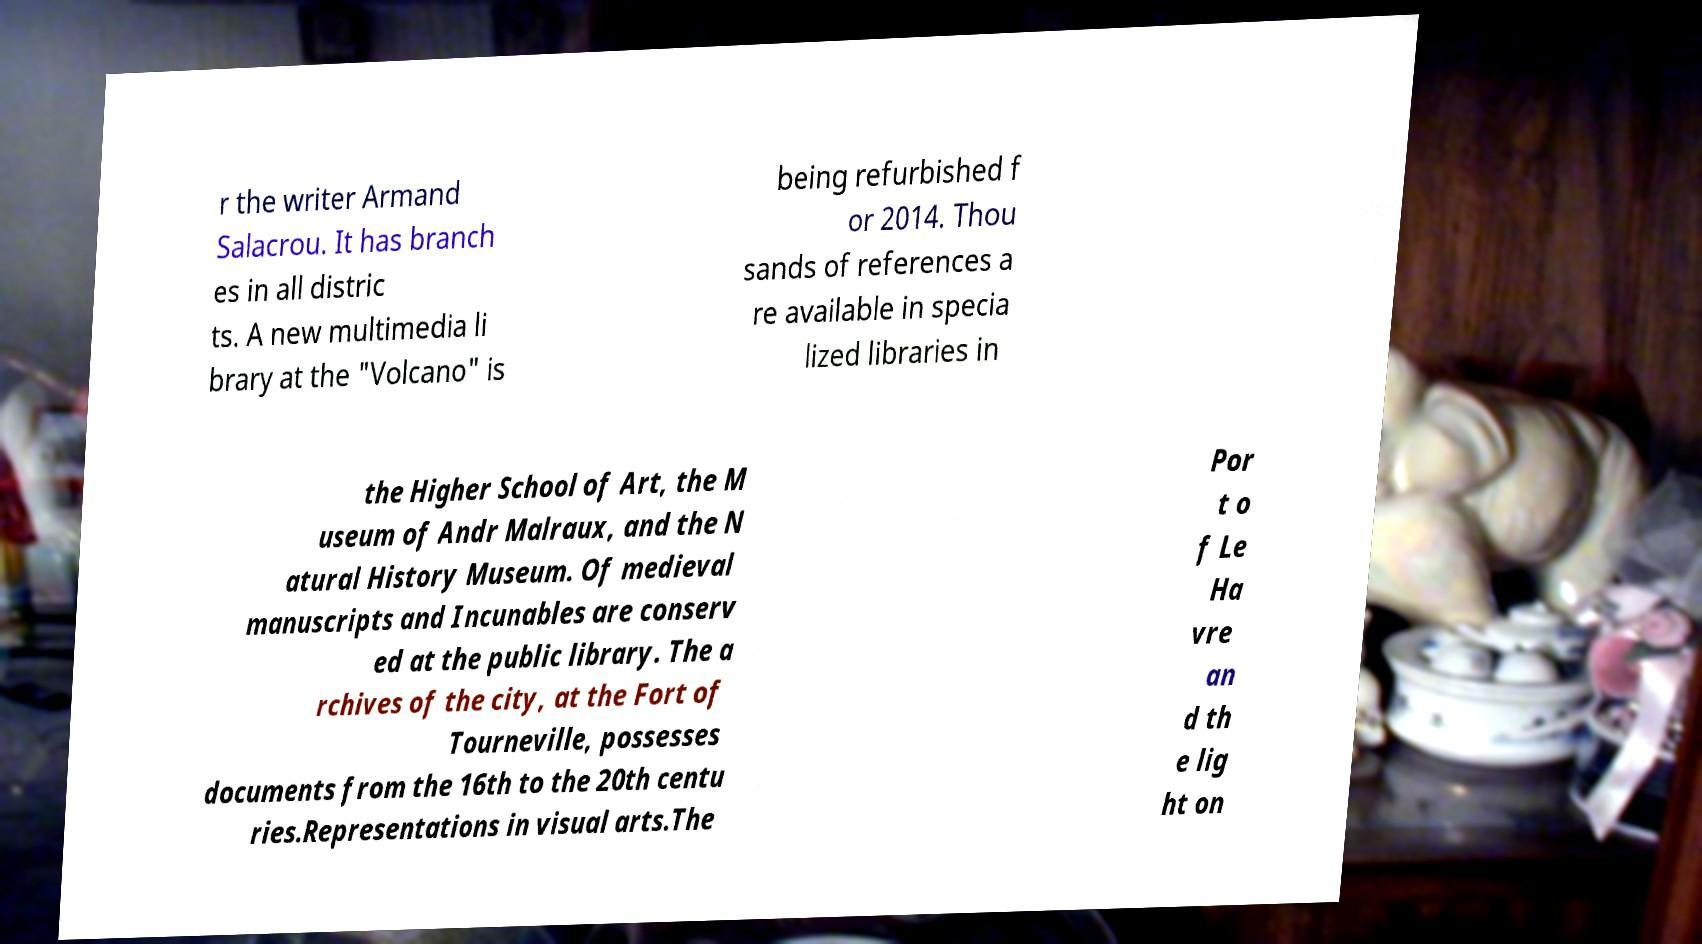What messages or text are displayed in this image? I need them in a readable, typed format. r the writer Armand Salacrou. It has branch es in all distric ts. A new multimedia li brary at the "Volcano" is being refurbished f or 2014. Thou sands of references a re available in specia lized libraries in the Higher School of Art, the M useum of Andr Malraux, and the N atural History Museum. Of medieval manuscripts and Incunables are conserv ed at the public library. The a rchives of the city, at the Fort of Tourneville, possesses documents from the 16th to the 20th centu ries.Representations in visual arts.The Por t o f Le Ha vre an d th e lig ht on 